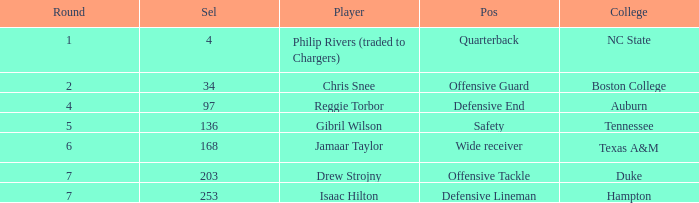Which Selection has a College of texas a&m? 168.0. 